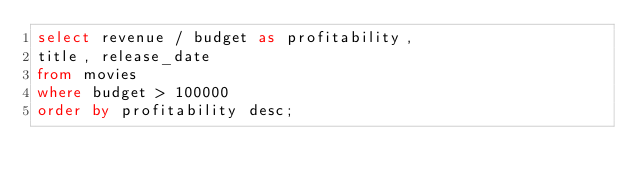<code> <loc_0><loc_0><loc_500><loc_500><_SQL_>select revenue / budget as profitability,
title, release_date
from movies
where budget > 100000
order by profitability desc;</code> 